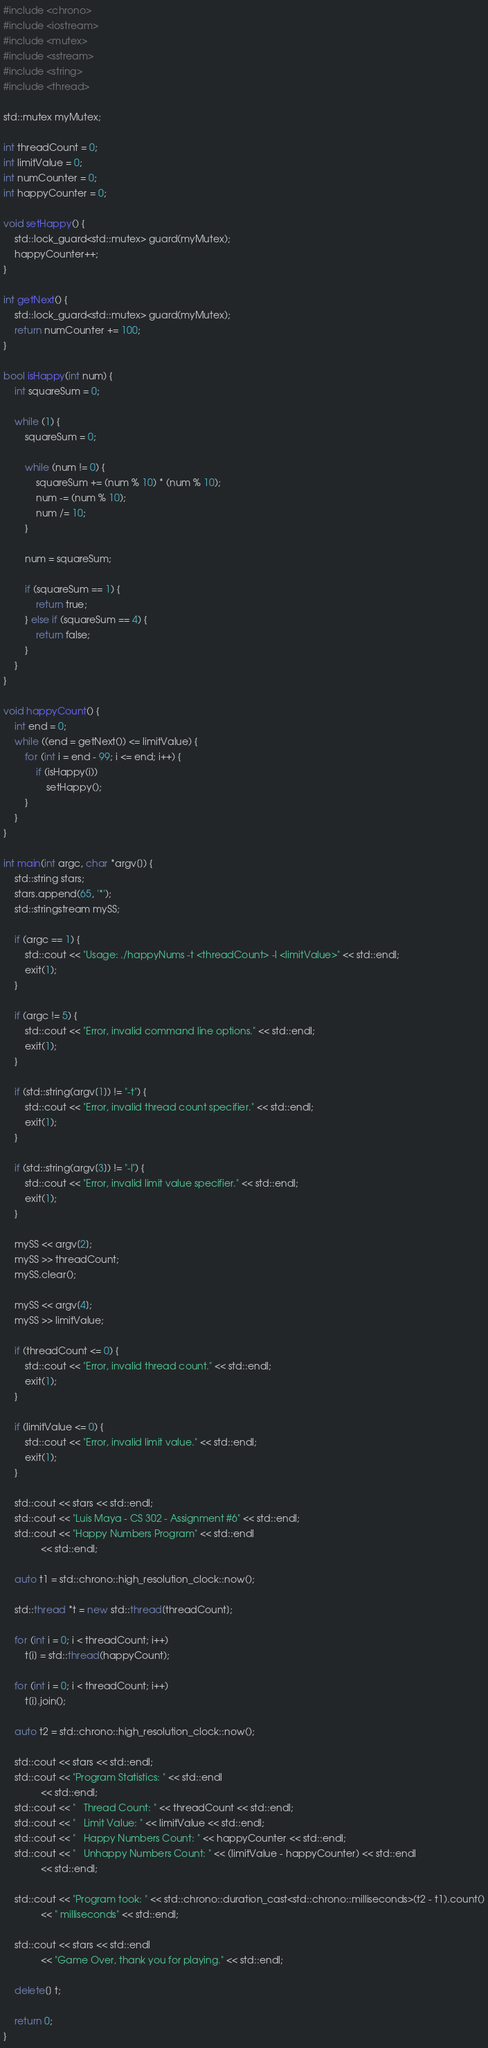Convert code to text. <code><loc_0><loc_0><loc_500><loc_500><_C++_>#include <chrono>
#include <iostream>
#include <mutex>
#include <sstream>
#include <string>
#include <thread>

std::mutex myMutex;

int threadCount = 0;
int limitValue = 0;
int numCounter = 0;
int happyCounter = 0;

void setHappy() {
    std::lock_guard<std::mutex> guard(myMutex);
    happyCounter++;
}

int getNext() {
    std::lock_guard<std::mutex> guard(myMutex);
    return numCounter += 100;
}

bool isHappy(int num) {
    int squareSum = 0;

    while (1) {
        squareSum = 0;

        while (num != 0) {
            squareSum += (num % 10) * (num % 10);
            num -= (num % 10);
            num /= 10;
        }

        num = squareSum;

        if (squareSum == 1) {
            return true;
        } else if (squareSum == 4) {
            return false;
        }
    }
}

void happyCount() {
    int end = 0;
    while ((end = getNext()) <= limitValue) {
        for (int i = end - 99; i <= end; i++) {
            if (isHappy(i))
                setHappy();
        }
    }
}

int main(int argc, char *argv[]) {
    std::string stars;
    stars.append(65, '*');
    std::stringstream mySS;

    if (argc == 1) {
        std::cout << "Usage: ./happyNums -t <threadCount> -l <limitValue>" << std::endl;
        exit(1);
    }

    if (argc != 5) {
        std::cout << "Error, invalid command line options." << std::endl;
        exit(1);
    }

    if (std::string(argv[1]) != "-t") {
        std::cout << "Error, invalid thread count specifier." << std::endl;
        exit(1);
    }

    if (std::string(argv[3]) != "-l") {
        std::cout << "Error, invalid limit value specifier." << std::endl;
        exit(1);
    }

    mySS << argv[2];
    mySS >> threadCount;
    mySS.clear();

    mySS << argv[4];
    mySS >> limitValue;

    if (threadCount <= 0) {
        std::cout << "Error, invalid thread count." << std::endl;
        exit(1);
    }

    if (limitValue <= 0) {
        std::cout << "Error, invalid limit value." << std::endl;
        exit(1);
    }

    std::cout << stars << std::endl;
    std::cout << "Luis Maya - CS 302 - Assignment #6" << std::endl;
    std::cout << "Happy Numbers Program" << std::endl
              << std::endl;

    auto t1 = std::chrono::high_resolution_clock::now();

    std::thread *t = new std::thread[threadCount];

    for (int i = 0; i < threadCount; i++)
        t[i] = std::thread(happyCount);

    for (int i = 0; i < threadCount; i++)
        t[i].join();

    auto t2 = std::chrono::high_resolution_clock::now();

    std::cout << stars << std::endl;
    std::cout << "Program Statistics: " << std::endl
              << std::endl;
    std::cout << "   Thread Count: " << threadCount << std::endl;
    std::cout << "   Limit Value: " << limitValue << std::endl;
    std::cout << "   Happy Numbers Count: " << happyCounter << std::endl;
    std::cout << "   Unhappy Numbers Count: " << (limitValue - happyCounter) << std::endl
              << std::endl;

    std::cout << "Program took: " << std::chrono::duration_cast<std::chrono::milliseconds>(t2 - t1).count()
              << " milliseconds" << std::endl;

    std::cout << stars << std::endl
              << "Game Over, thank you for playing." << std::endl;

    delete[] t;

    return 0;
}
</code> 